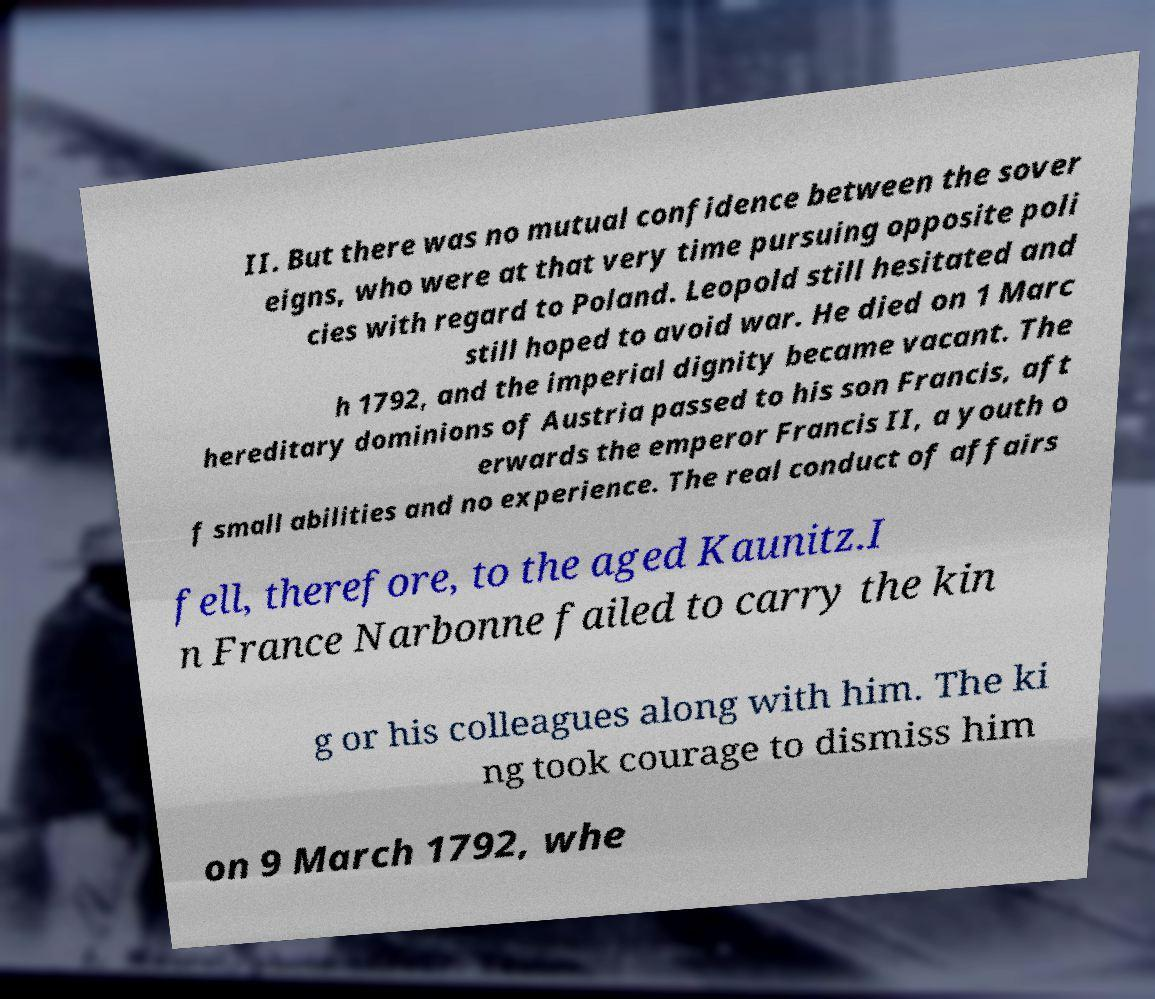Can you read and provide the text displayed in the image?This photo seems to have some interesting text. Can you extract and type it out for me? II. But there was no mutual confidence between the sover eigns, who were at that very time pursuing opposite poli cies with regard to Poland. Leopold still hesitated and still hoped to avoid war. He died on 1 Marc h 1792, and the imperial dignity became vacant. The hereditary dominions of Austria passed to his son Francis, aft erwards the emperor Francis II, a youth o f small abilities and no experience. The real conduct of affairs fell, therefore, to the aged Kaunitz.I n France Narbonne failed to carry the kin g or his colleagues along with him. The ki ng took courage to dismiss him on 9 March 1792, whe 